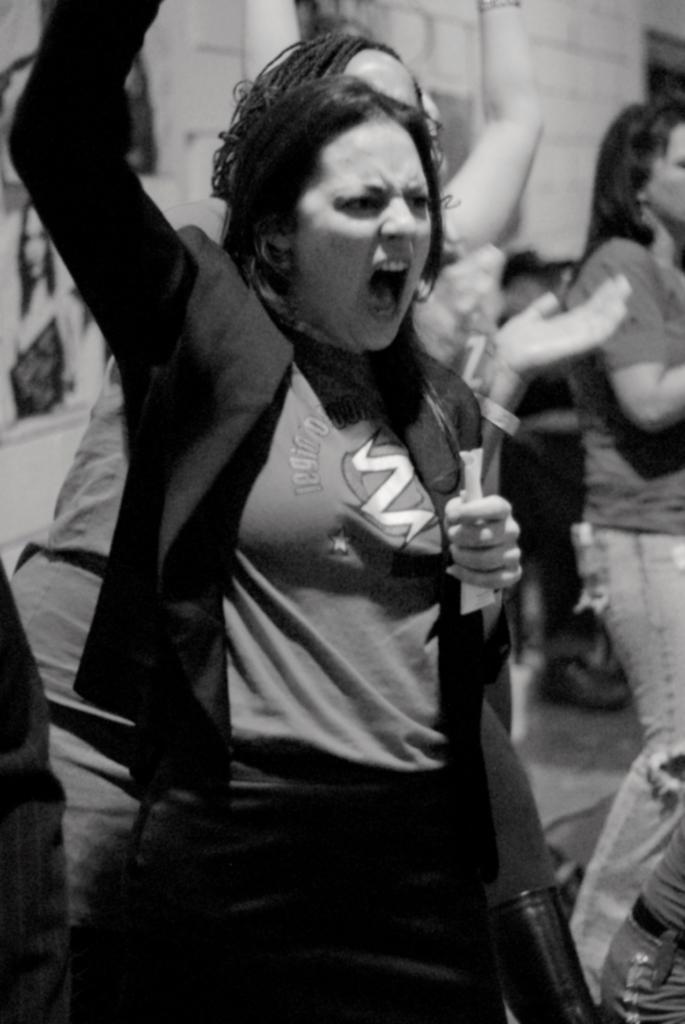Could you give a brief overview of what you see in this image? This is an black and white image. In this image, in the middle, we can see a woman wearing a black color coat and she also holding something in her hand. In the background, we can see group of people and a wall. 